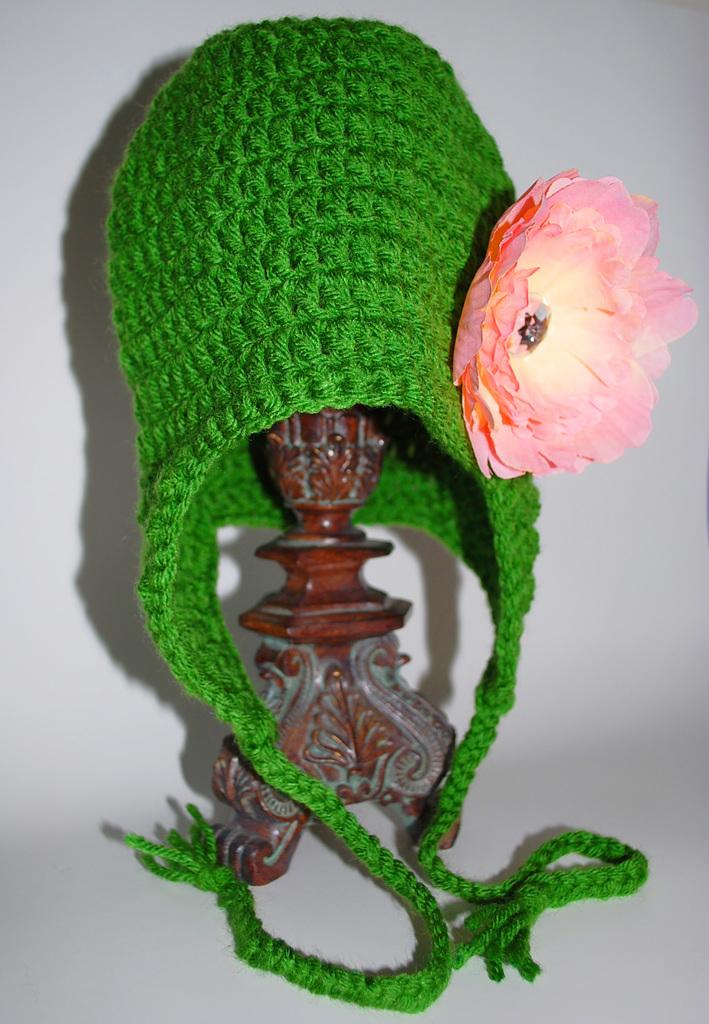What type of cap is featured in the image? There is a woolen cap with a flower in the image. Where is the woolen cap located? The woolen cap is on a stand. What is the stand placed on? The stand is placed on a surface. What type of flesh can be seen in the image? There is no flesh present in the image; it features a woolen cap with a flower on a stand. How does the jam contribute to the design of the woolen cap? There is no jam present in the image, and it does not contribute to the design of the woolen cap. 